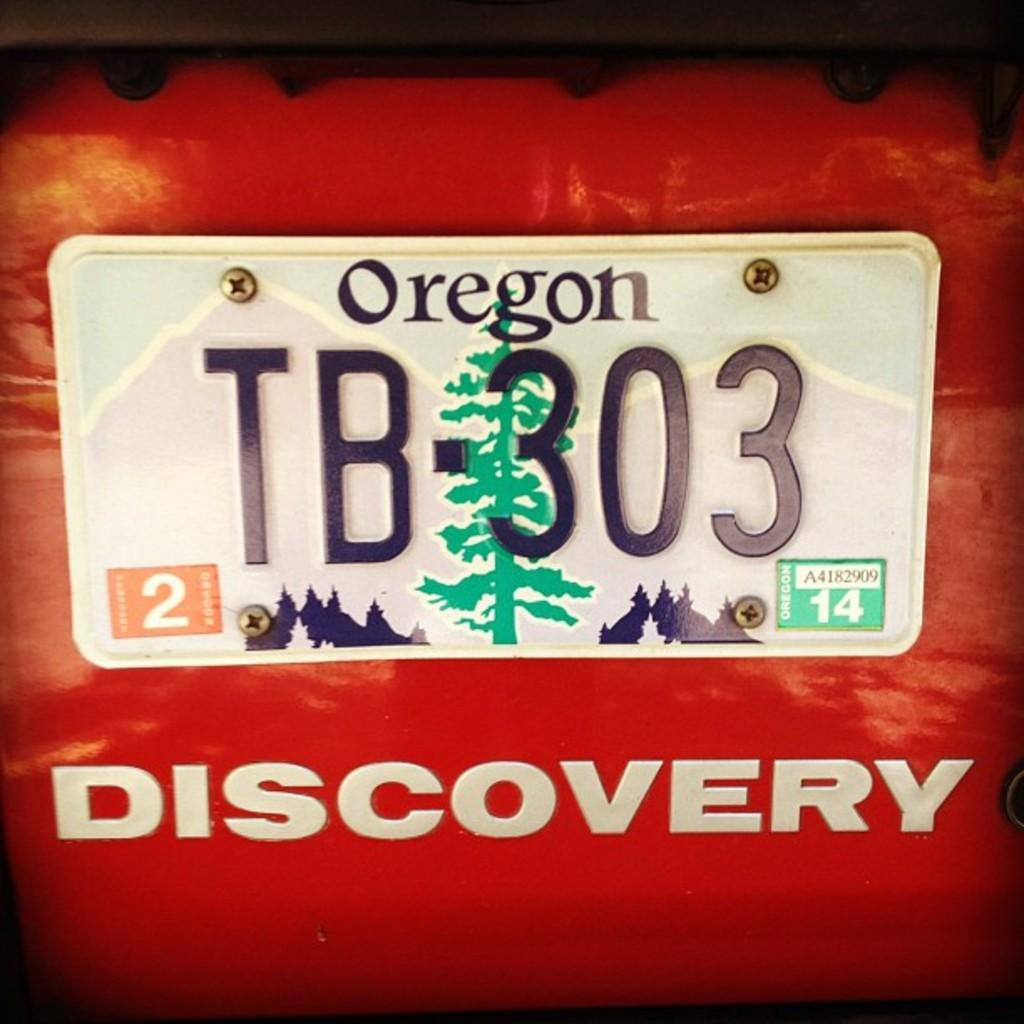<image>
Create a compact narrative representing the image presented. A red Discovery vehicle is from Oregon and has an evergreen tree on it. 